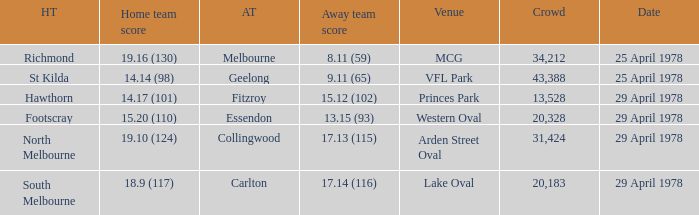In what venue was the hosted away team Essendon? Western Oval. Could you parse the entire table? {'header': ['HT', 'Home team score', 'AT', 'Away team score', 'Venue', 'Crowd', 'Date'], 'rows': [['Richmond', '19.16 (130)', 'Melbourne', '8.11 (59)', 'MCG', '34,212', '25 April 1978'], ['St Kilda', '14.14 (98)', 'Geelong', '9.11 (65)', 'VFL Park', '43,388', '25 April 1978'], ['Hawthorn', '14.17 (101)', 'Fitzroy', '15.12 (102)', 'Princes Park', '13,528', '29 April 1978'], ['Footscray', '15.20 (110)', 'Essendon', '13.15 (93)', 'Western Oval', '20,328', '29 April 1978'], ['North Melbourne', '19.10 (124)', 'Collingwood', '17.13 (115)', 'Arden Street Oval', '31,424', '29 April 1978'], ['South Melbourne', '18.9 (117)', 'Carlton', '17.14 (116)', 'Lake Oval', '20,183', '29 April 1978']]} 